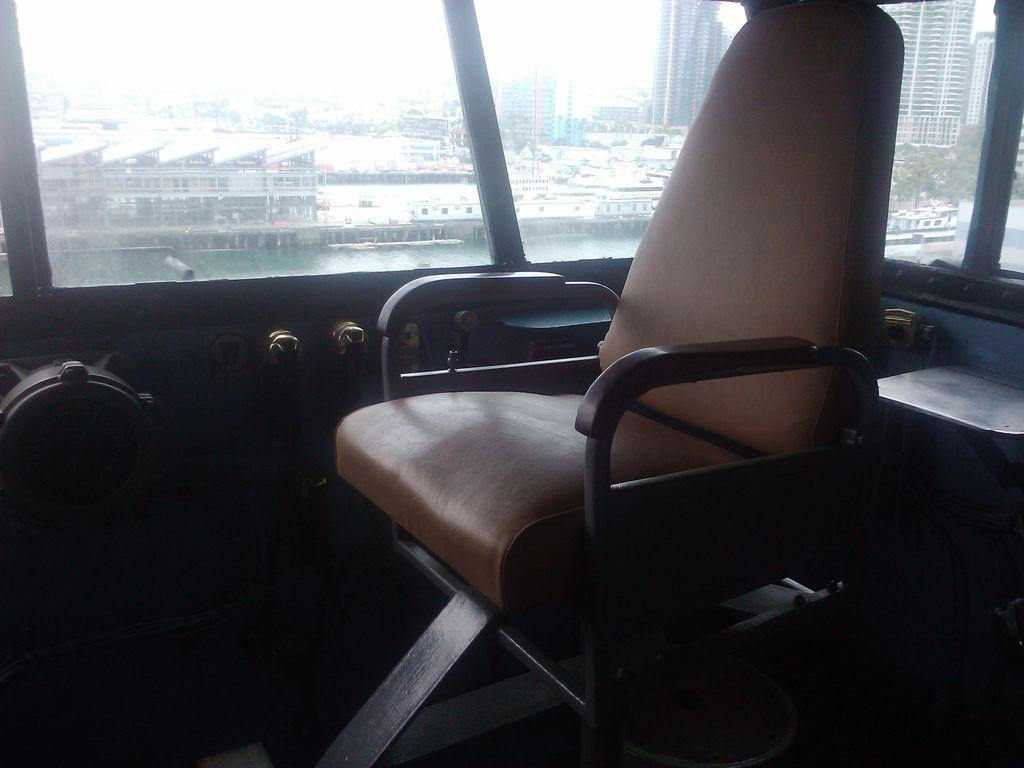What is unusual about the chair in the image? The chair is inside a vehicle in the image. What can be seen in the background of the image? Water, buildings, skyscrapers, trees, and the sky are visible in the background of the image. Can you describe the type of buildings in the background? Skyscrapers are present in the background of the image. How many cakes are being prepared on the chair inside the vehicle? There are no cakes present in the image; it features a chair inside a vehicle with a background of water, buildings, skyscrapers, trees, and the sky. 